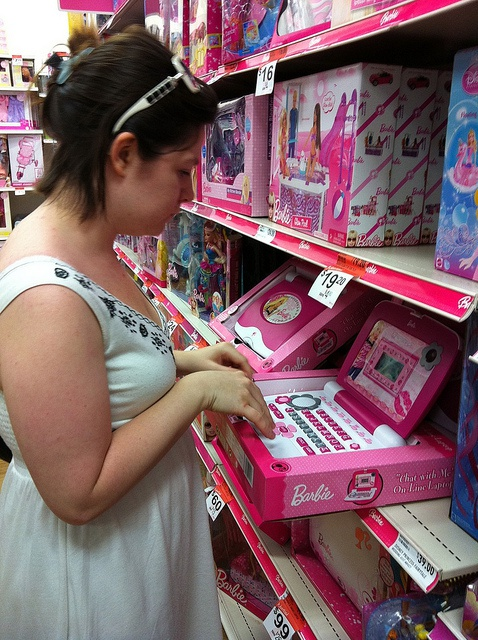Describe the objects in this image and their specific colors. I can see people in white, darkgray, brown, black, and gray tones, laptop in white, lightgray, purple, and black tones, and laptop in white, maroon, violet, and darkgray tones in this image. 